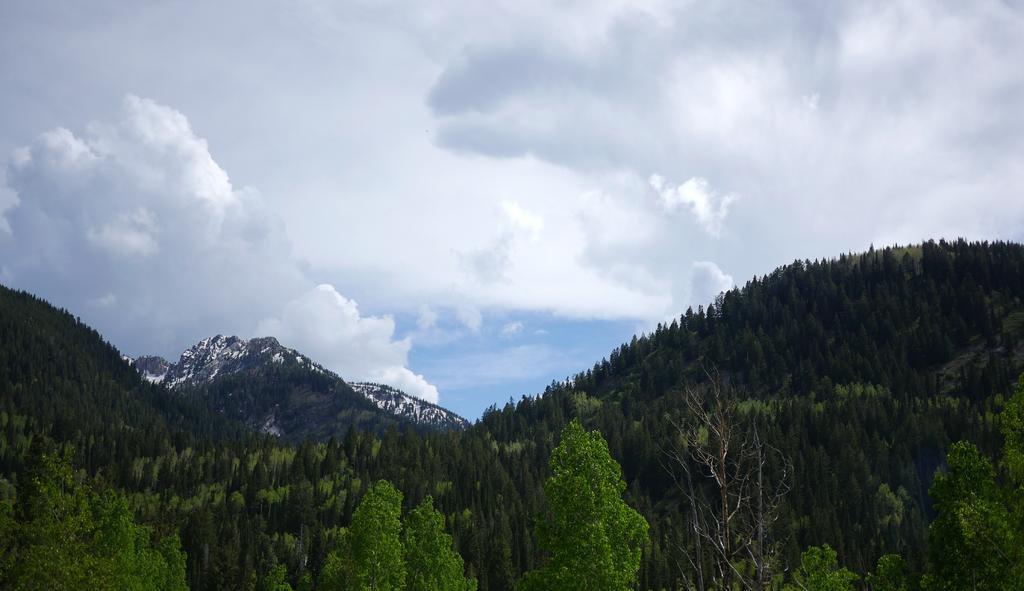Can you describe this image briefly? In the picture we can see the trees, hills and the sky with clouds. 